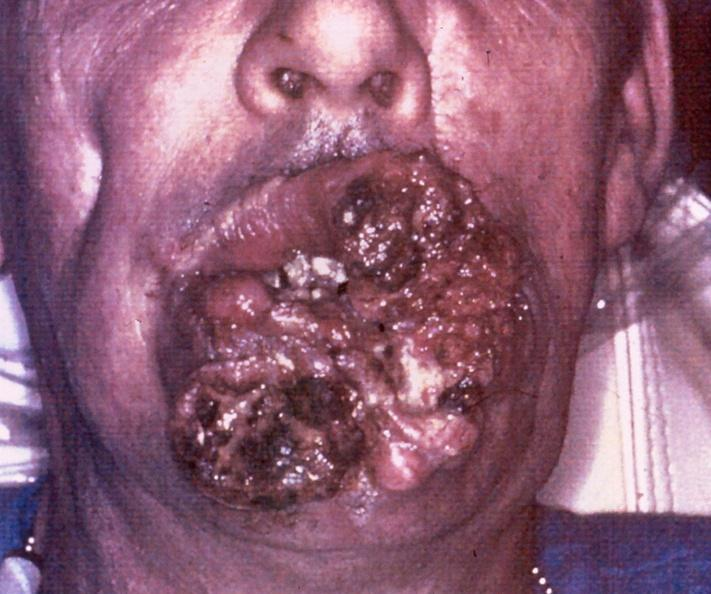does retroperitoneal leiomyosarcoma show squamous cell carcinoma, lip?
Answer the question using a single word or phrase. No 